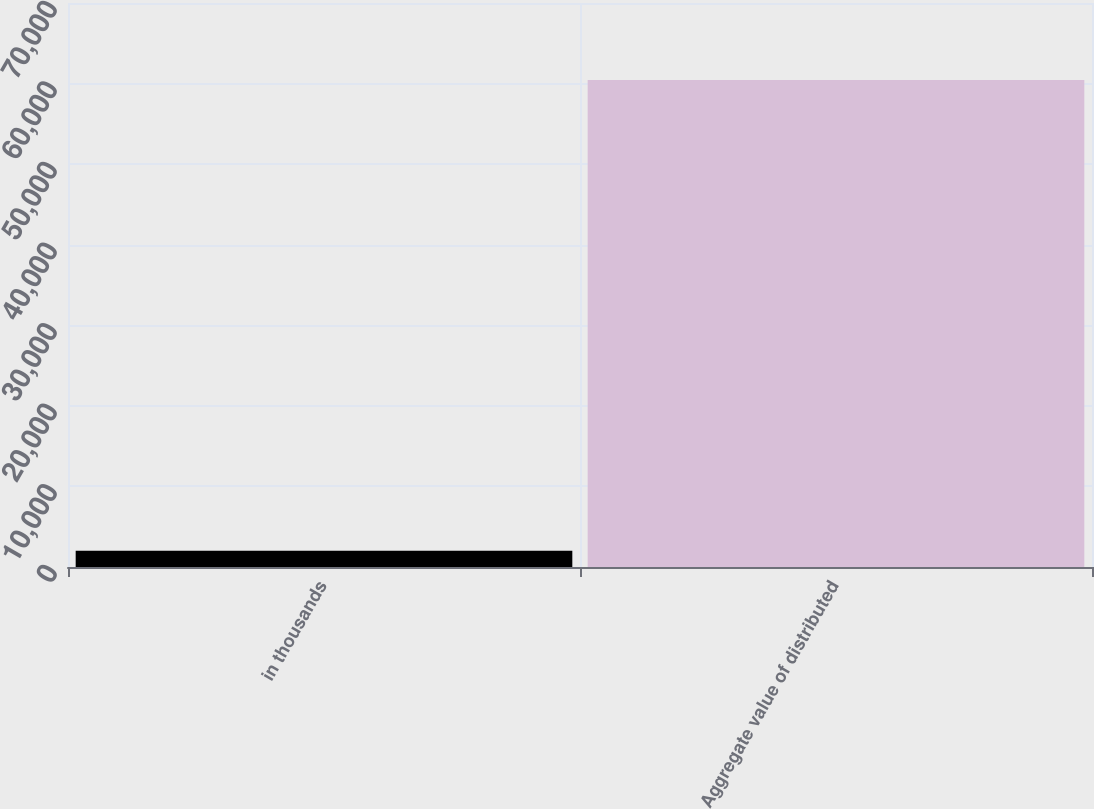<chart> <loc_0><loc_0><loc_500><loc_500><bar_chart><fcel>in thousands<fcel>Aggregate value of distributed<nl><fcel>2016<fcel>60443<nl></chart> 